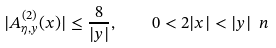Convert formula to latex. <formula><loc_0><loc_0><loc_500><loc_500>| A ^ { ( 2 ) } _ { \eta , y } ( x ) | \leq \frac { 8 } { | y | } , \quad 0 < 2 | x | < | y | \ n</formula> 